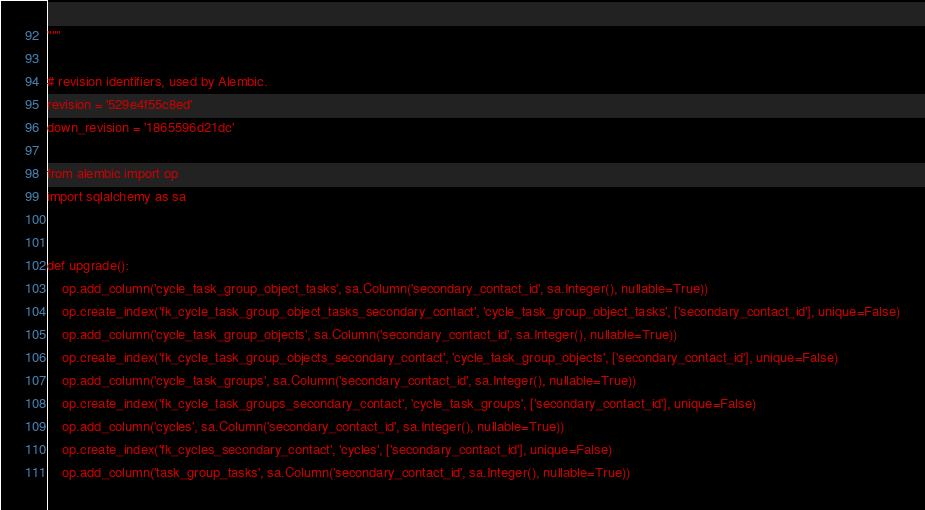<code> <loc_0><loc_0><loc_500><loc_500><_Python_>"""

# revision identifiers, used by Alembic.
revision = '529e4f55c8ed'
down_revision = '1865596d21dc'

from alembic import op
import sqlalchemy as sa


def upgrade():
    op.add_column('cycle_task_group_object_tasks', sa.Column('secondary_contact_id', sa.Integer(), nullable=True))
    op.create_index('fk_cycle_task_group_object_tasks_secondary_contact', 'cycle_task_group_object_tasks', ['secondary_contact_id'], unique=False)
    op.add_column('cycle_task_group_objects', sa.Column('secondary_contact_id', sa.Integer(), nullable=True))
    op.create_index('fk_cycle_task_group_objects_secondary_contact', 'cycle_task_group_objects', ['secondary_contact_id'], unique=False)
    op.add_column('cycle_task_groups', sa.Column('secondary_contact_id', sa.Integer(), nullable=True))
    op.create_index('fk_cycle_task_groups_secondary_contact', 'cycle_task_groups', ['secondary_contact_id'], unique=False)
    op.add_column('cycles', sa.Column('secondary_contact_id', sa.Integer(), nullable=True))
    op.create_index('fk_cycles_secondary_contact', 'cycles', ['secondary_contact_id'], unique=False)
    op.add_column('task_group_tasks', sa.Column('secondary_contact_id', sa.Integer(), nullable=True))</code> 